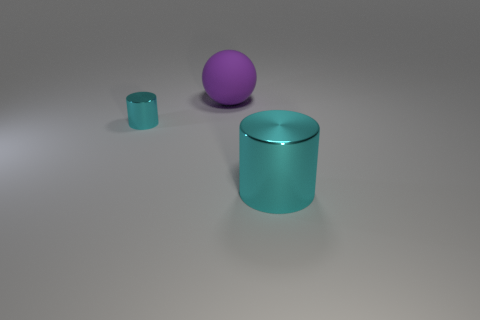Is the color of the thing to the right of the large purple sphere the same as the big thing that is behind the tiny cyan cylinder? No, the color of the object to the right of the large purple sphere, which is a small cyan cylinder, is not the same as the color of the larger cyan cylinder behind it. The larger object has a more pronounced teal hue, likely due to lighting and shadows in the image. 